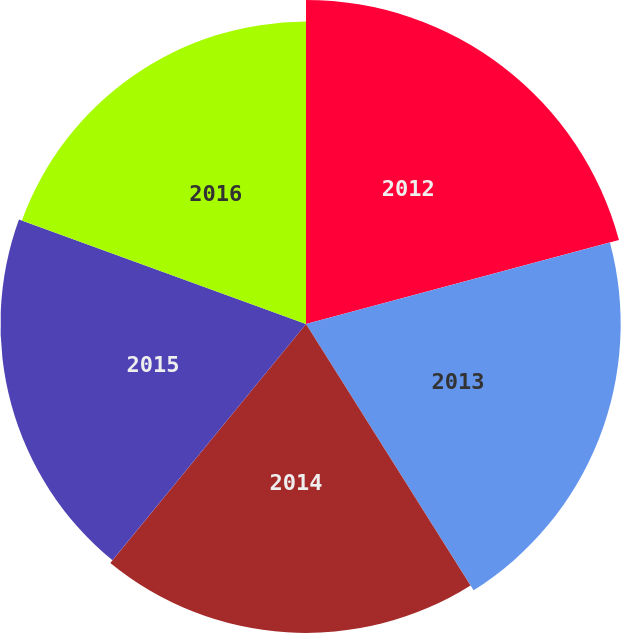Convert chart. <chart><loc_0><loc_0><loc_500><loc_500><pie_chart><fcel>2012<fcel>2013<fcel>2014<fcel>2015<fcel>2016<nl><fcel>20.83%<fcel>20.23%<fcel>19.86%<fcel>19.64%<fcel>19.44%<nl></chart> 